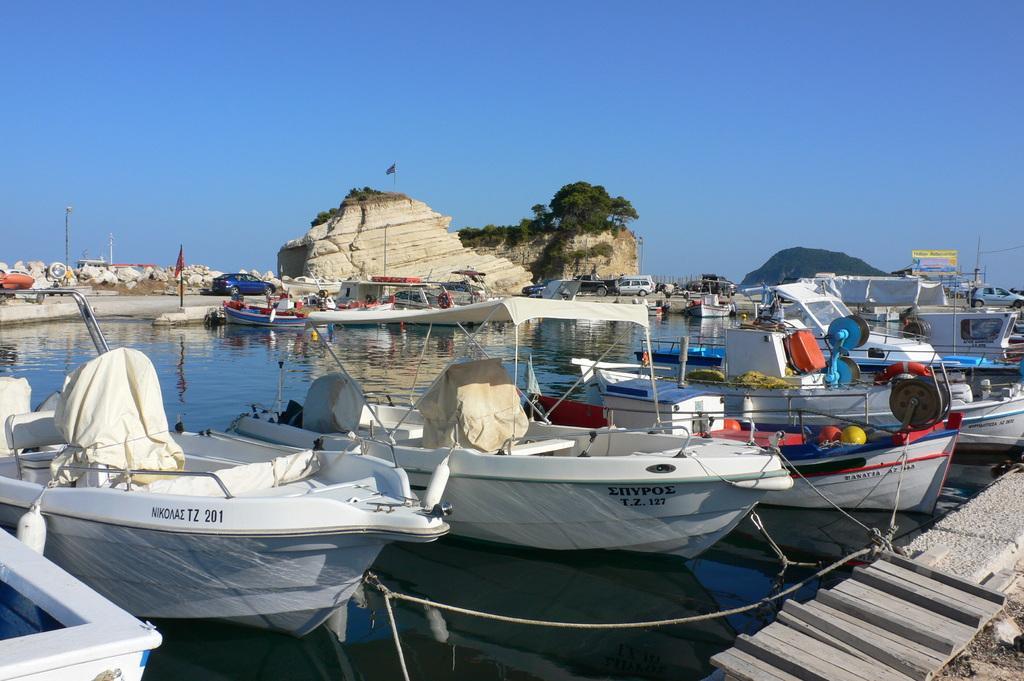Can you describe this image briefly? In this picture we can see there are boats on the water and the boats are tied with ropes. Behind the boats there are poles, hills, trees, some vehicles on the path and sky. 